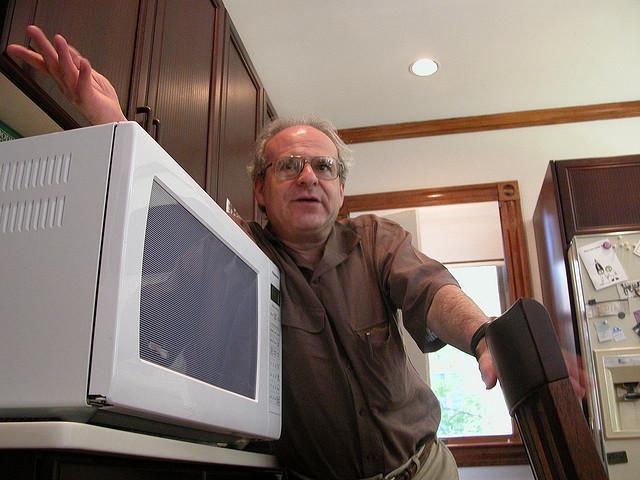How many lights are visible?
Give a very brief answer. 1. How many people are there?
Give a very brief answer. 1. How many clocks have red numbers?
Give a very brief answer. 0. 